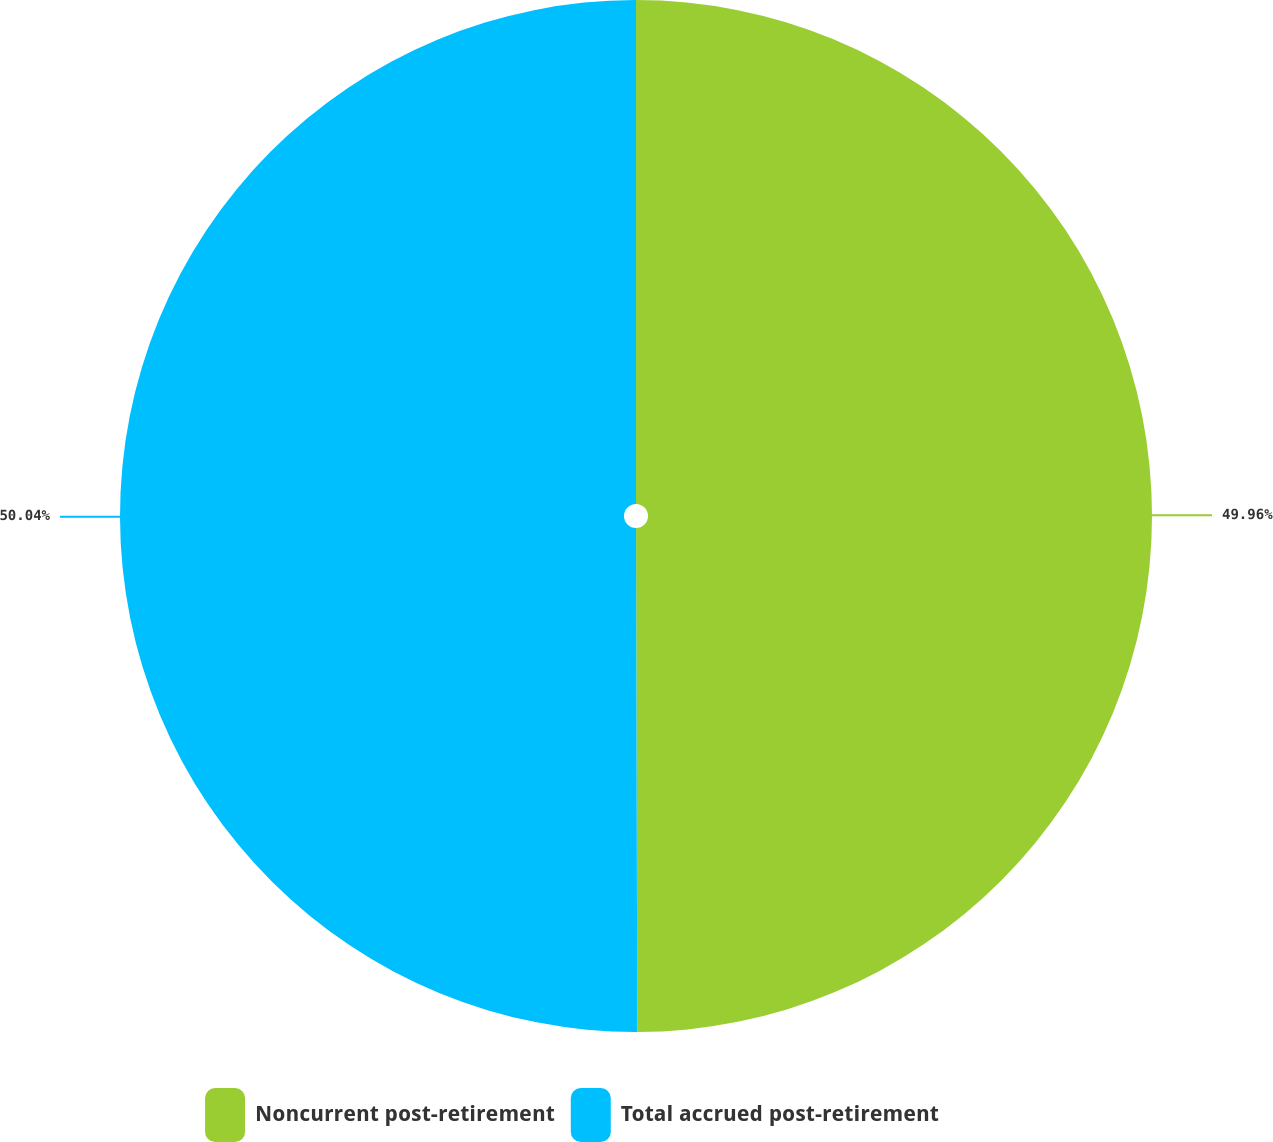<chart> <loc_0><loc_0><loc_500><loc_500><pie_chart><fcel>Noncurrent post-retirement<fcel>Total accrued post-retirement<nl><fcel>49.96%<fcel>50.04%<nl></chart> 